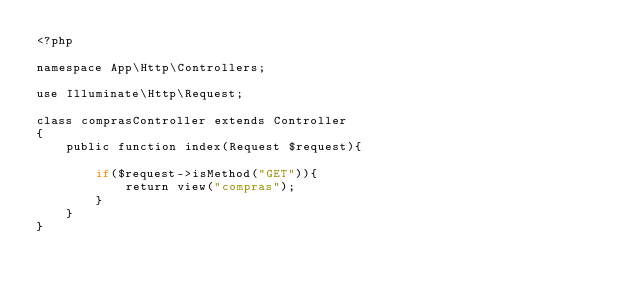<code> <loc_0><loc_0><loc_500><loc_500><_PHP_><?php

namespace App\Http\Controllers;

use Illuminate\Http\Request;

class comprasController extends Controller
{
    public function index(Request $request){

        if($request->isMethod("GET")){
            return view("compras");
        }
    }
}
</code> 